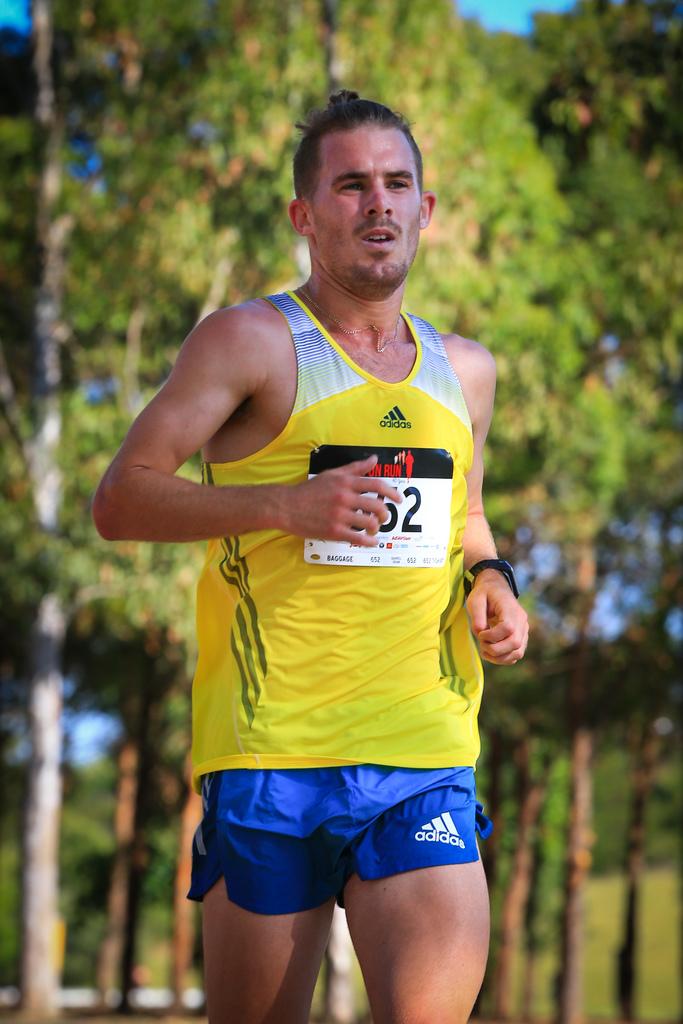What brand are the runner's shorts?
Give a very brief answer. Adidas. 